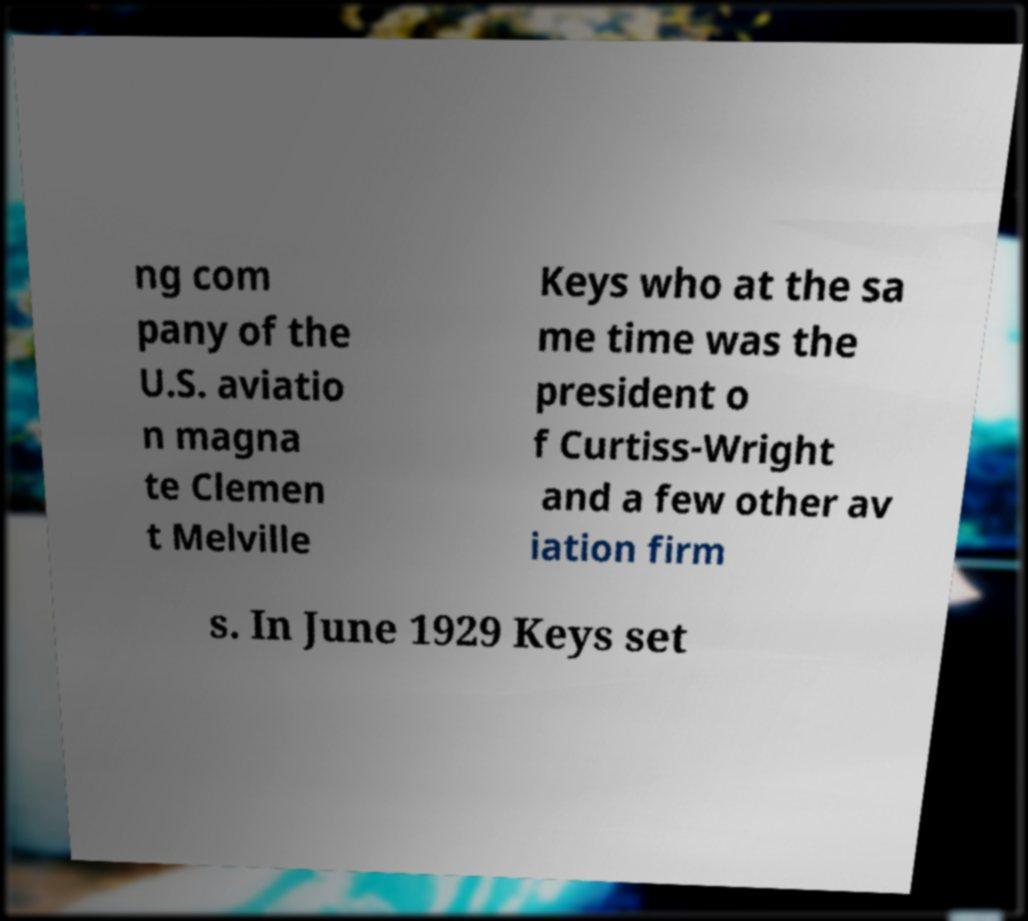There's text embedded in this image that I need extracted. Can you transcribe it verbatim? ng com pany of the U.S. aviatio n magna te Clemen t Melville Keys who at the sa me time was the president o f Curtiss-Wright and a few other av iation firm s. In June 1929 Keys set 